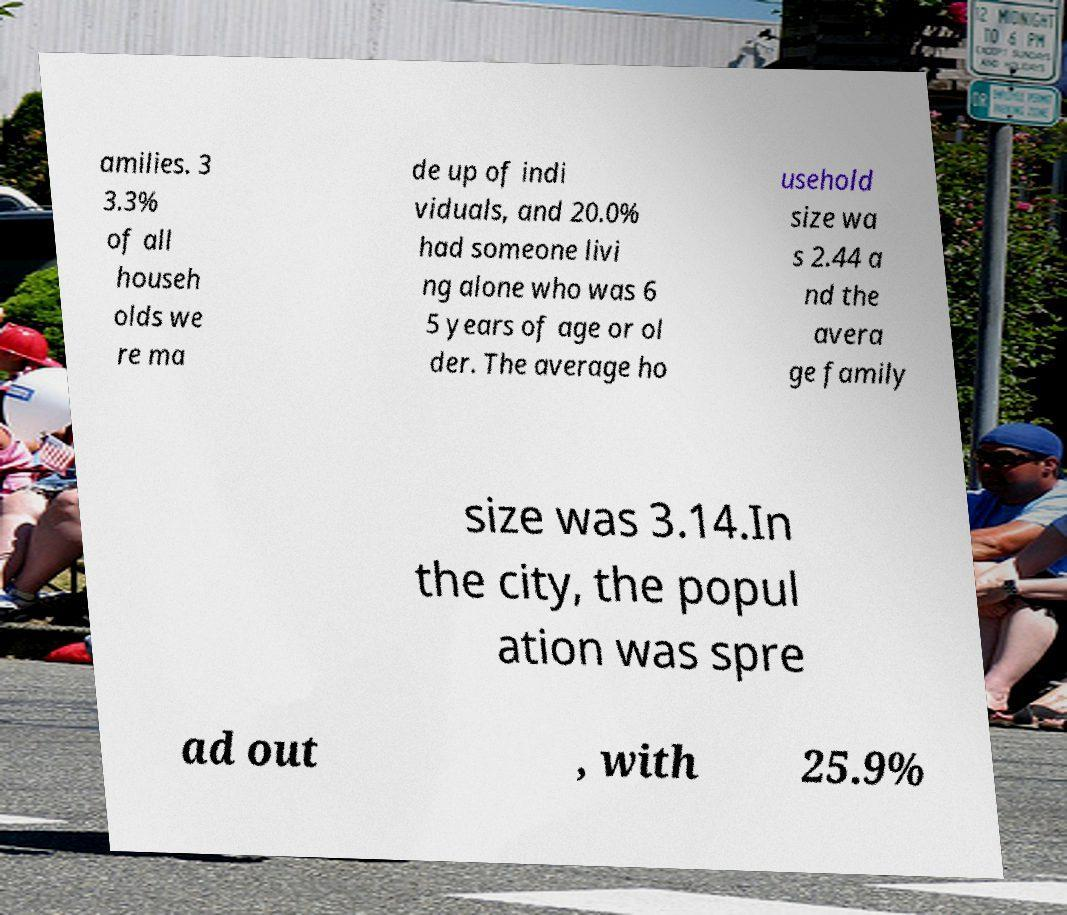What messages or text are displayed in this image? I need them in a readable, typed format. amilies. 3 3.3% of all househ olds we re ma de up of indi viduals, and 20.0% had someone livi ng alone who was 6 5 years of age or ol der. The average ho usehold size wa s 2.44 a nd the avera ge family size was 3.14.In the city, the popul ation was spre ad out , with 25.9% 